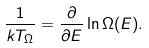Convert formula to latex. <formula><loc_0><loc_0><loc_500><loc_500>\frac { 1 } { k T _ { \Omega } } = \frac { \partial } { \partial E } \ln \Omega ( E ) .</formula> 